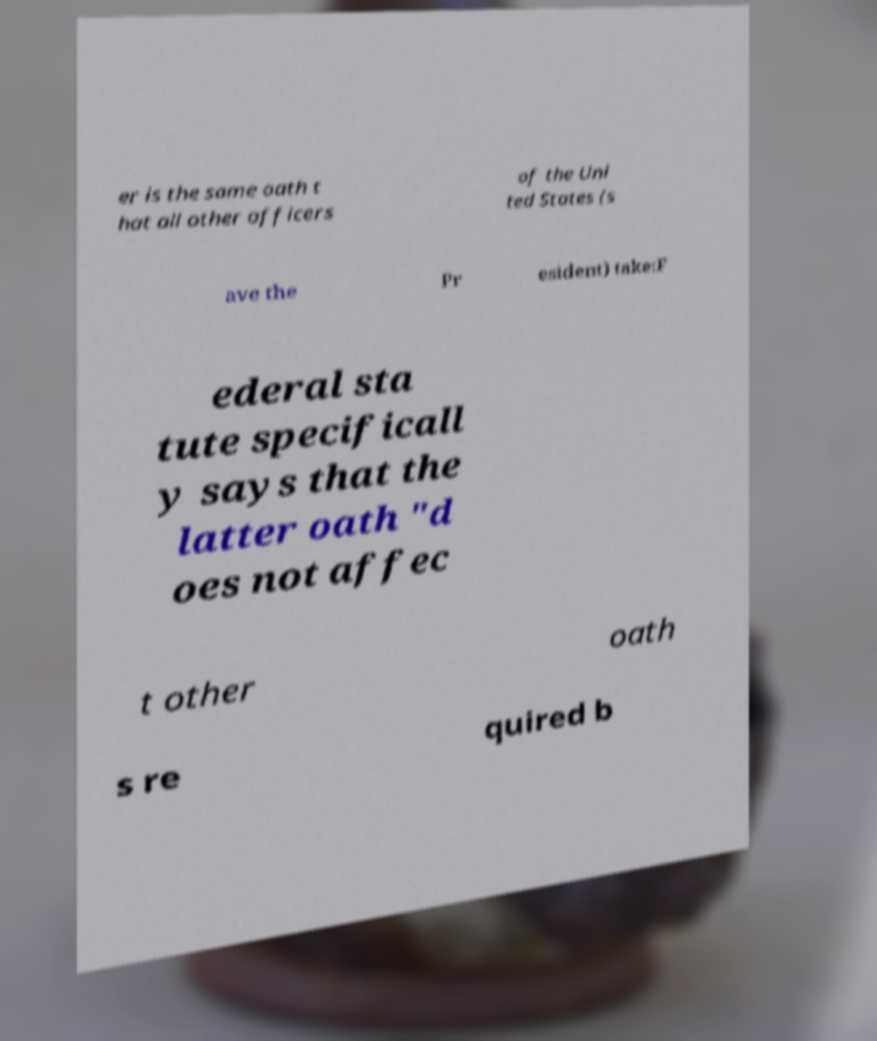What messages or text are displayed in this image? I need them in a readable, typed format. er is the same oath t hat all other officers of the Uni ted States (s ave the Pr esident) take:F ederal sta tute specificall y says that the latter oath "d oes not affec t other oath s re quired b 